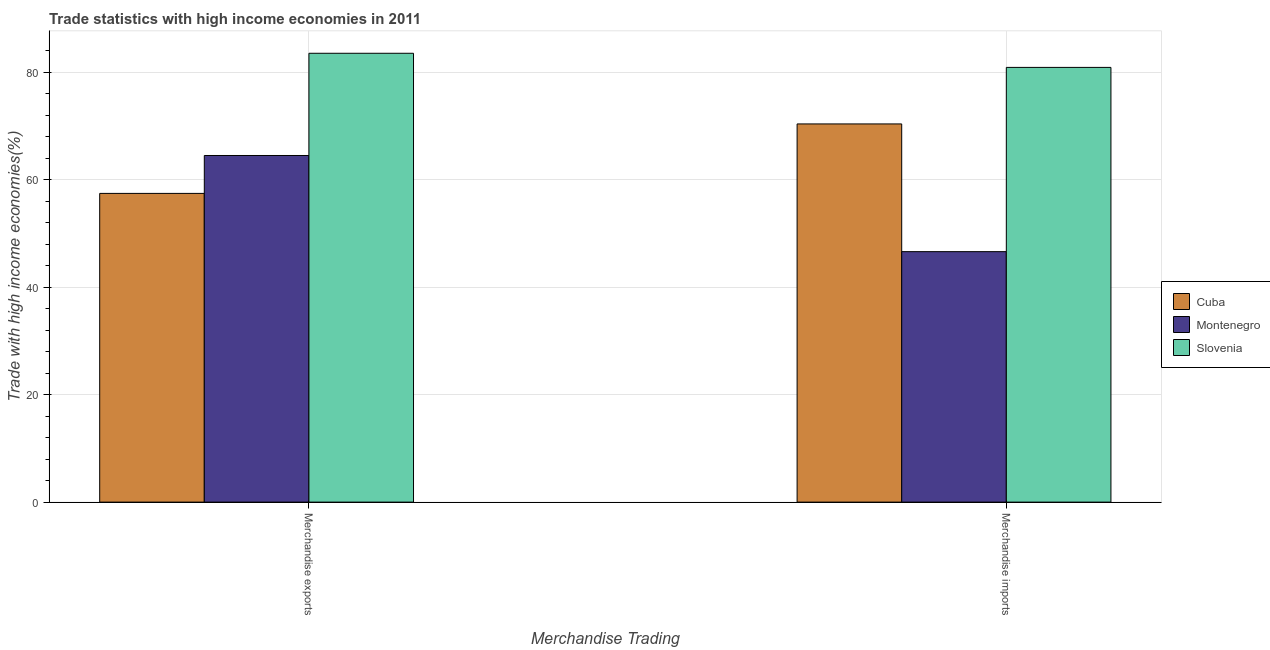How many different coloured bars are there?
Your response must be concise. 3. How many groups of bars are there?
Your answer should be compact. 2. What is the merchandise imports in Slovenia?
Offer a terse response. 80.88. Across all countries, what is the maximum merchandise exports?
Your response must be concise. 83.51. Across all countries, what is the minimum merchandise imports?
Ensure brevity in your answer.  46.6. In which country was the merchandise exports maximum?
Offer a very short reply. Slovenia. In which country was the merchandise exports minimum?
Your answer should be very brief. Cuba. What is the total merchandise imports in the graph?
Offer a terse response. 197.85. What is the difference between the merchandise imports in Cuba and that in Slovenia?
Provide a succinct answer. -10.52. What is the difference between the merchandise exports in Cuba and the merchandise imports in Montenegro?
Ensure brevity in your answer.  10.84. What is the average merchandise exports per country?
Make the answer very short. 68.48. What is the difference between the merchandise imports and merchandise exports in Montenegro?
Ensure brevity in your answer.  -17.89. In how many countries, is the merchandise exports greater than 4 %?
Your answer should be very brief. 3. What is the ratio of the merchandise imports in Cuba to that in Slovenia?
Make the answer very short. 0.87. Is the merchandise imports in Slovenia less than that in Montenegro?
Your answer should be very brief. No. What does the 1st bar from the left in Merchandise exports represents?
Ensure brevity in your answer.  Cuba. What does the 2nd bar from the right in Merchandise imports represents?
Offer a terse response. Montenegro. How many bars are there?
Your answer should be very brief. 6. Are all the bars in the graph horizontal?
Provide a short and direct response. No. How many countries are there in the graph?
Your response must be concise. 3. Are the values on the major ticks of Y-axis written in scientific E-notation?
Offer a very short reply. No. How are the legend labels stacked?
Ensure brevity in your answer.  Vertical. What is the title of the graph?
Provide a short and direct response. Trade statistics with high income economies in 2011. Does "Syrian Arab Republic" appear as one of the legend labels in the graph?
Make the answer very short. No. What is the label or title of the X-axis?
Ensure brevity in your answer.  Merchandise Trading. What is the label or title of the Y-axis?
Offer a terse response. Trade with high income economies(%). What is the Trade with high income economies(%) in Cuba in Merchandise exports?
Provide a succinct answer. 57.44. What is the Trade with high income economies(%) in Montenegro in Merchandise exports?
Provide a short and direct response. 64.49. What is the Trade with high income economies(%) in Slovenia in Merchandise exports?
Your answer should be very brief. 83.51. What is the Trade with high income economies(%) of Cuba in Merchandise imports?
Offer a very short reply. 70.36. What is the Trade with high income economies(%) of Montenegro in Merchandise imports?
Keep it short and to the point. 46.6. What is the Trade with high income economies(%) of Slovenia in Merchandise imports?
Ensure brevity in your answer.  80.88. Across all Merchandise Trading, what is the maximum Trade with high income economies(%) in Cuba?
Your response must be concise. 70.36. Across all Merchandise Trading, what is the maximum Trade with high income economies(%) in Montenegro?
Give a very brief answer. 64.49. Across all Merchandise Trading, what is the maximum Trade with high income economies(%) in Slovenia?
Your answer should be very brief. 83.51. Across all Merchandise Trading, what is the minimum Trade with high income economies(%) of Cuba?
Your response must be concise. 57.44. Across all Merchandise Trading, what is the minimum Trade with high income economies(%) in Montenegro?
Give a very brief answer. 46.6. Across all Merchandise Trading, what is the minimum Trade with high income economies(%) in Slovenia?
Your answer should be very brief. 80.88. What is the total Trade with high income economies(%) in Cuba in the graph?
Provide a succinct answer. 127.81. What is the total Trade with high income economies(%) of Montenegro in the graph?
Make the answer very short. 111.1. What is the total Trade with high income economies(%) of Slovenia in the graph?
Provide a short and direct response. 164.4. What is the difference between the Trade with high income economies(%) in Cuba in Merchandise exports and that in Merchandise imports?
Give a very brief answer. -12.92. What is the difference between the Trade with high income economies(%) of Montenegro in Merchandise exports and that in Merchandise imports?
Ensure brevity in your answer.  17.89. What is the difference between the Trade with high income economies(%) of Slovenia in Merchandise exports and that in Merchandise imports?
Your response must be concise. 2.63. What is the difference between the Trade with high income economies(%) in Cuba in Merchandise exports and the Trade with high income economies(%) in Montenegro in Merchandise imports?
Offer a very short reply. 10.84. What is the difference between the Trade with high income economies(%) of Cuba in Merchandise exports and the Trade with high income economies(%) of Slovenia in Merchandise imports?
Provide a succinct answer. -23.44. What is the difference between the Trade with high income economies(%) in Montenegro in Merchandise exports and the Trade with high income economies(%) in Slovenia in Merchandise imports?
Make the answer very short. -16.39. What is the average Trade with high income economies(%) of Cuba per Merchandise Trading?
Provide a short and direct response. 63.9. What is the average Trade with high income economies(%) in Montenegro per Merchandise Trading?
Your answer should be compact. 55.55. What is the average Trade with high income economies(%) of Slovenia per Merchandise Trading?
Offer a very short reply. 82.2. What is the difference between the Trade with high income economies(%) of Cuba and Trade with high income economies(%) of Montenegro in Merchandise exports?
Ensure brevity in your answer.  -7.05. What is the difference between the Trade with high income economies(%) in Cuba and Trade with high income economies(%) in Slovenia in Merchandise exports?
Give a very brief answer. -26.07. What is the difference between the Trade with high income economies(%) of Montenegro and Trade with high income economies(%) of Slovenia in Merchandise exports?
Give a very brief answer. -19.02. What is the difference between the Trade with high income economies(%) in Cuba and Trade with high income economies(%) in Montenegro in Merchandise imports?
Offer a terse response. 23.76. What is the difference between the Trade with high income economies(%) of Cuba and Trade with high income economies(%) of Slovenia in Merchandise imports?
Your answer should be very brief. -10.52. What is the difference between the Trade with high income economies(%) in Montenegro and Trade with high income economies(%) in Slovenia in Merchandise imports?
Give a very brief answer. -34.28. What is the ratio of the Trade with high income economies(%) in Cuba in Merchandise exports to that in Merchandise imports?
Ensure brevity in your answer.  0.82. What is the ratio of the Trade with high income economies(%) of Montenegro in Merchandise exports to that in Merchandise imports?
Offer a terse response. 1.38. What is the ratio of the Trade with high income economies(%) in Slovenia in Merchandise exports to that in Merchandise imports?
Your response must be concise. 1.03. What is the difference between the highest and the second highest Trade with high income economies(%) in Cuba?
Your response must be concise. 12.92. What is the difference between the highest and the second highest Trade with high income economies(%) in Montenegro?
Give a very brief answer. 17.89. What is the difference between the highest and the second highest Trade with high income economies(%) in Slovenia?
Your answer should be compact. 2.63. What is the difference between the highest and the lowest Trade with high income economies(%) of Cuba?
Keep it short and to the point. 12.92. What is the difference between the highest and the lowest Trade with high income economies(%) in Montenegro?
Your answer should be compact. 17.89. What is the difference between the highest and the lowest Trade with high income economies(%) of Slovenia?
Ensure brevity in your answer.  2.63. 